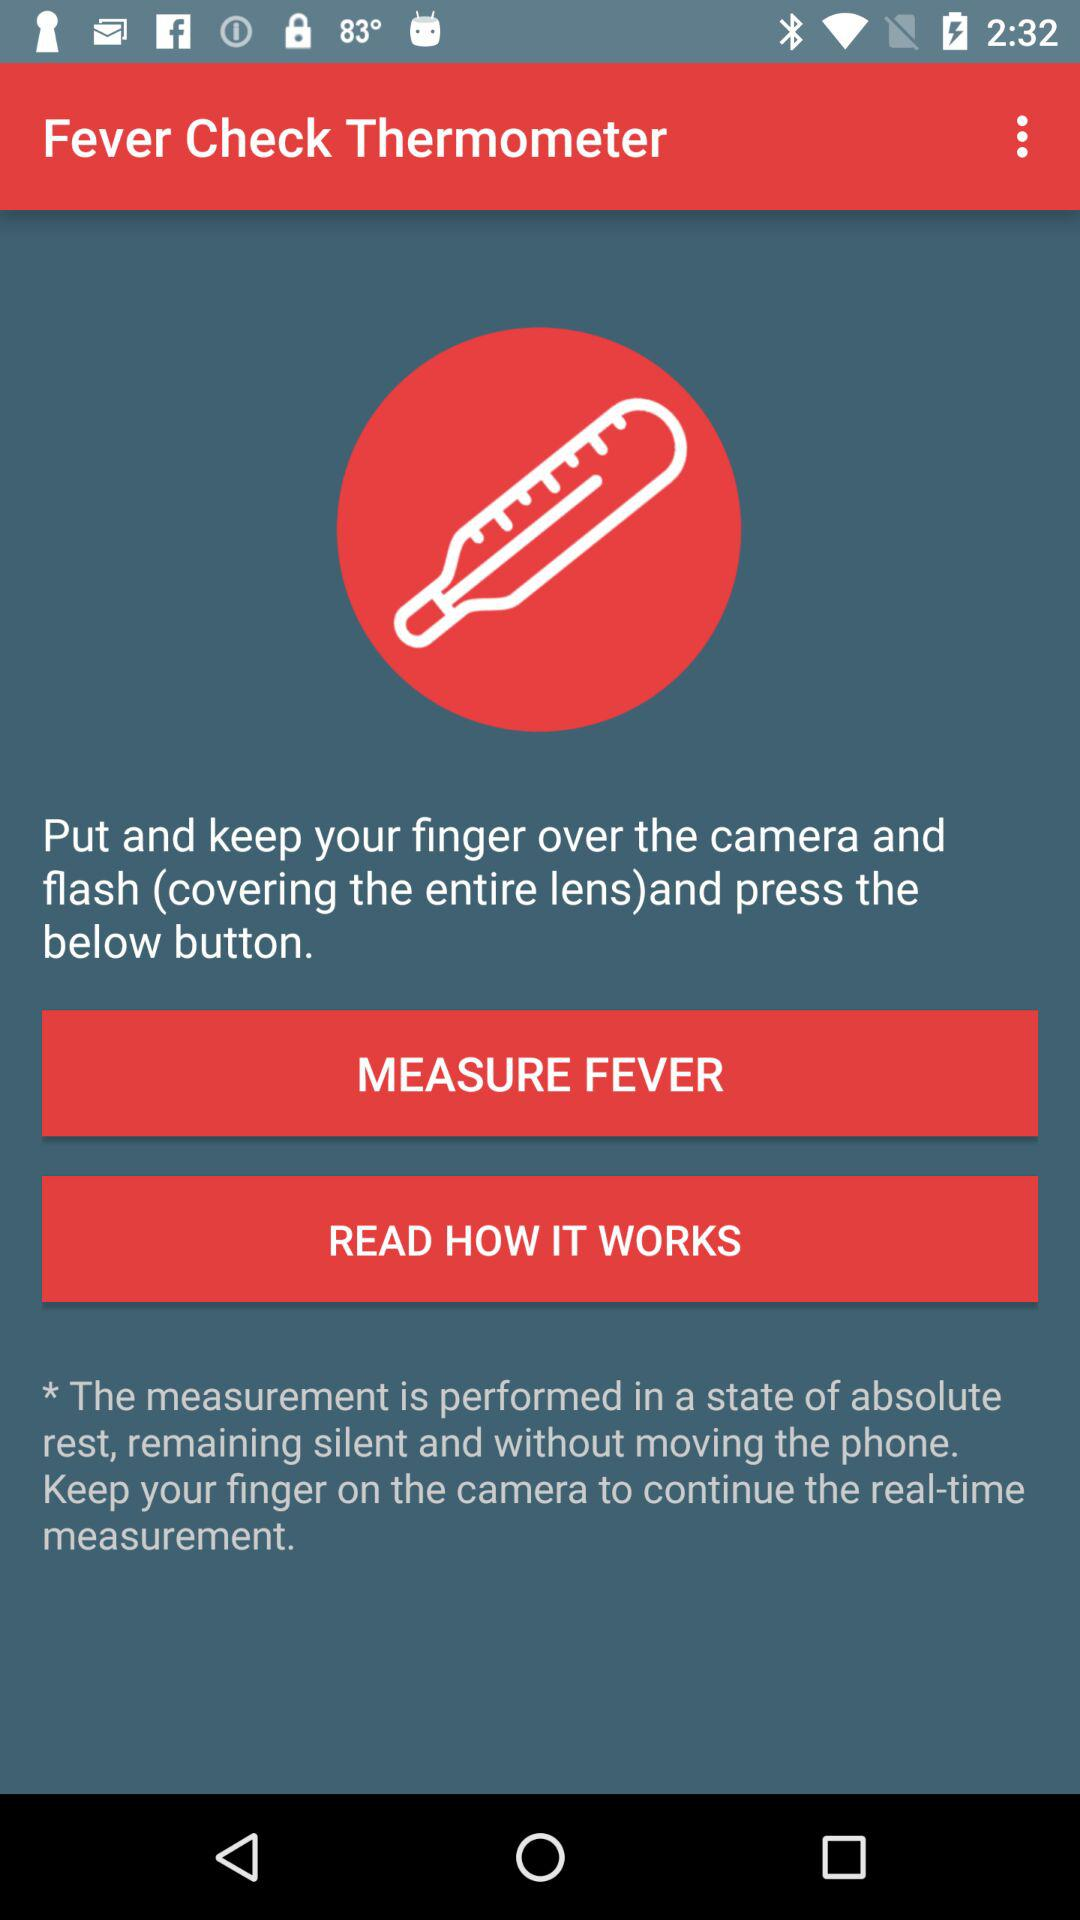What is the name of the application? The name of the application is "Fever Check Thermometer". 